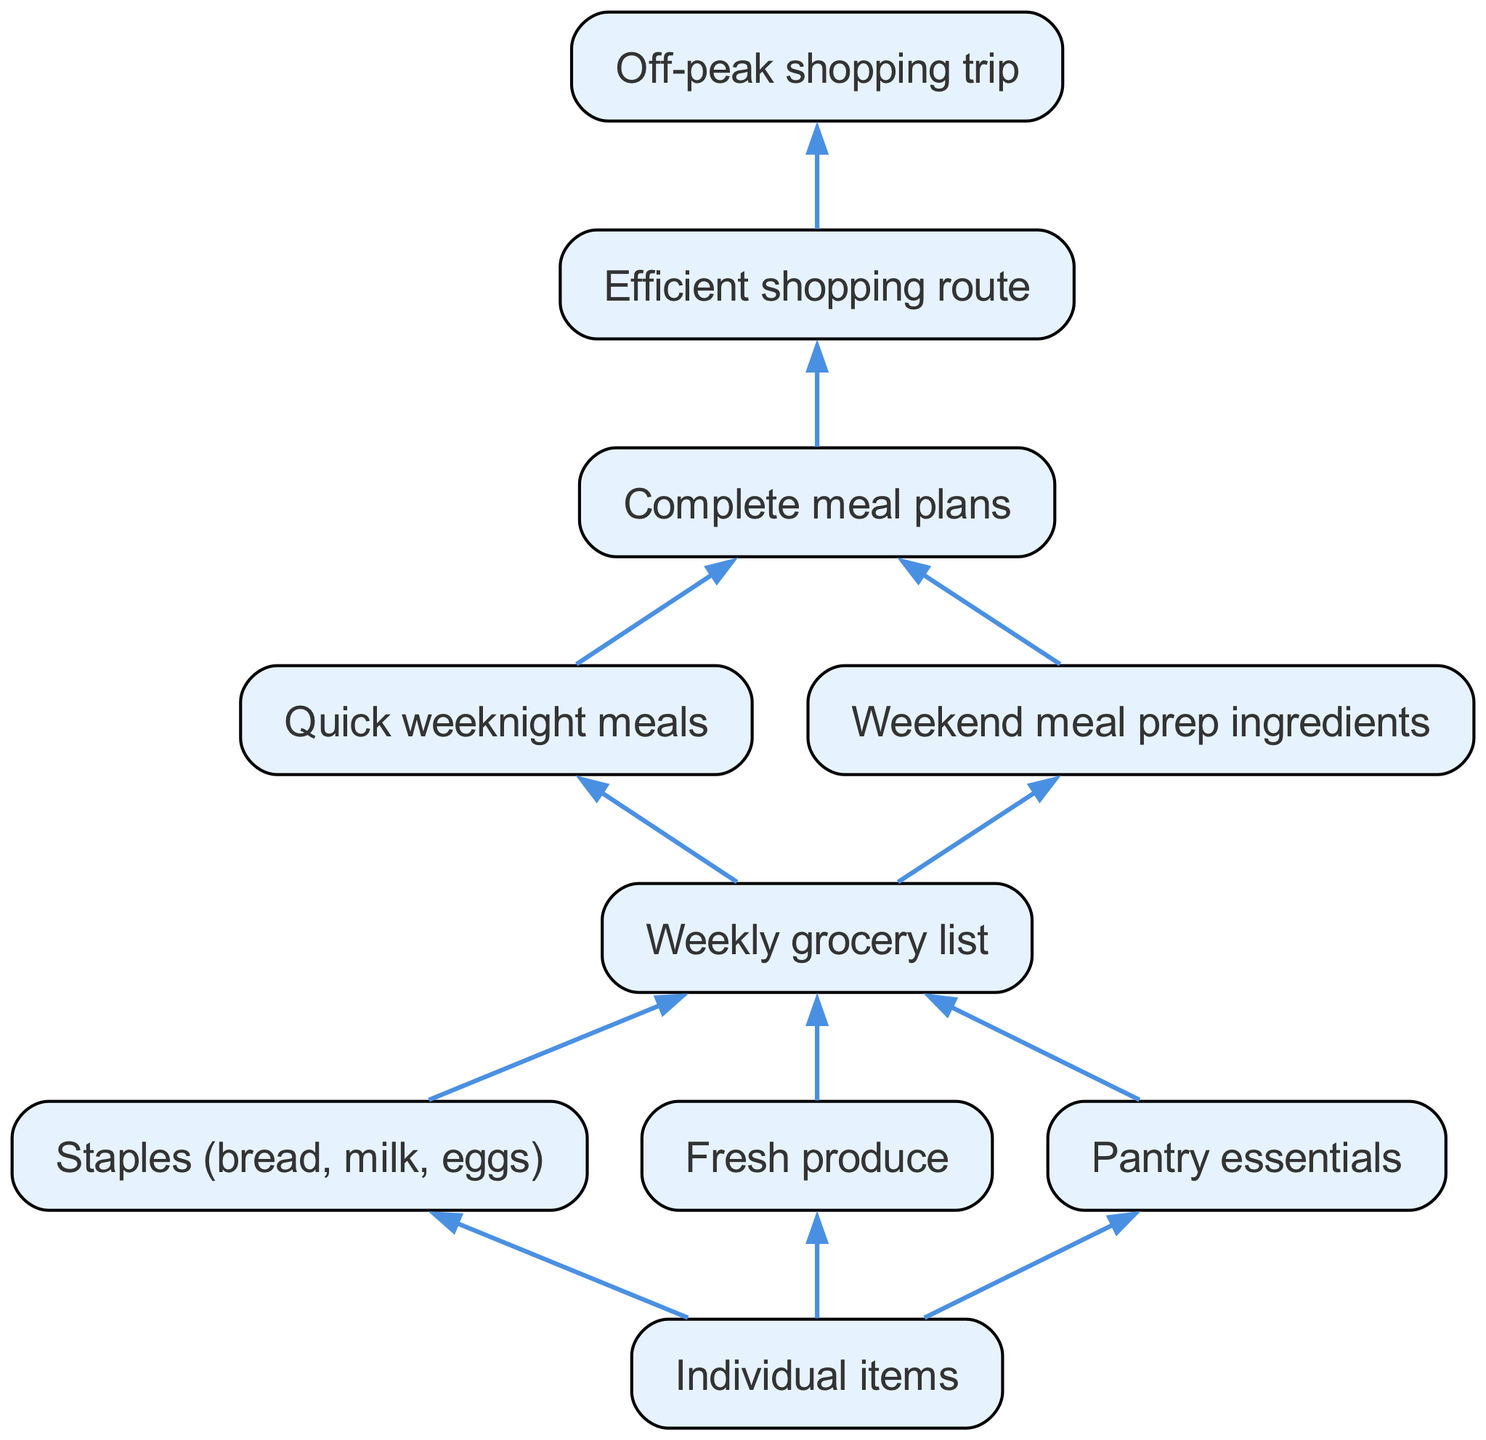What are the categories of individual items? The diagram shows three categories under individual items: staples, fresh produce, and pantry essentials. These categories help in organizing the grocery selection process.
Answer: staples, fresh produce, pantry essentials How many total nodes are in the diagram? By counting the individual items, weekly grocery list, complete meal plans, and other nodes, we determine there are 10 nodes in total. This includes all the elements shown in the flow chart.
Answer: 10 What is the final step in the shopping process? The ends of the flow chart show that the final step, after planning and preparing items, is an off-peak shopping trip, emphasizing efficient shopping.
Answer: Off-peak shopping trip Which node leads directly to the efficient shopping route? The weekly grocery list is the node that directly leads to the efficient shopping route, as it organizes what needs to be bought in a structured manner.
Answer: Weekly grocery list How many kinds of meal planning are included? The diagram indicates two types of meal planning: quick weeknight meals and weekend meal prep ingredients, each contributing to the overall meal planning strategy.
Answer: 2 What are the components under the weekly grocery list? The weekly grocery list consists of two main components: quick weeknight meals and weekend meal prep ingredients, which help in meal preparation and shopping preparation.
Answer: Quick weeknight meals, Weekend meal prep ingredients What is the relationship between individual items and the weekly grocery list? Individual items (staples, fresh produce, pantry essentials) are the building blocks that are gathered to create the weekly grocery list, indicating a bottom-up approach to grocery selection.
Answer: Building blocks Which element is at the top of the hierarchy? The diagram's structure clearly shows that individual items represent the starting point of the hierarchy, leading towards the complete meal plans and efficient shopping route.
Answer: Individual items What is the purpose of the efficient shopping route in the diagram? The efficient shopping route serves to streamline the grocery shopping process, ensuring that the shopper can complete their visits without unnecessary delays, focusing on off-peak hours.
Answer: Streamline the grocery shopping process 